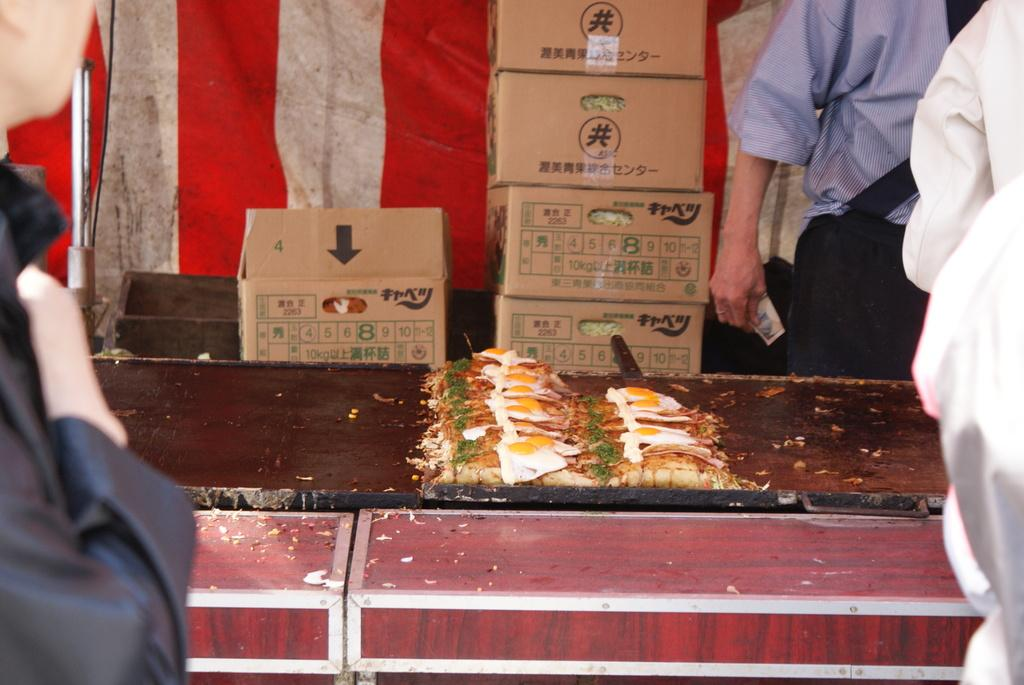What is on the platform in the image? There is food on a platform in the image. Can you describe the people in the image? There are people in the image, but their specific actions or characteristics are not mentioned in the provided facts. What can be seen in the background of the image? There are cardboard boxes in the background of the image. What type of shoe is being used as a serving utensil for the food in the image? There is no shoe present in the image, and therefore it cannot be used as a serving utensil for the food. 